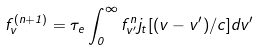Convert formula to latex. <formula><loc_0><loc_0><loc_500><loc_500>f _ { v } ^ { ( n + 1 ) } = \tau _ { e } \int _ { 0 } ^ { \infty } f _ { v ^ { \prime } } ^ { n } j _ { t } [ ( v - v ^ { \prime } ) / c ] d v ^ { \prime }</formula> 